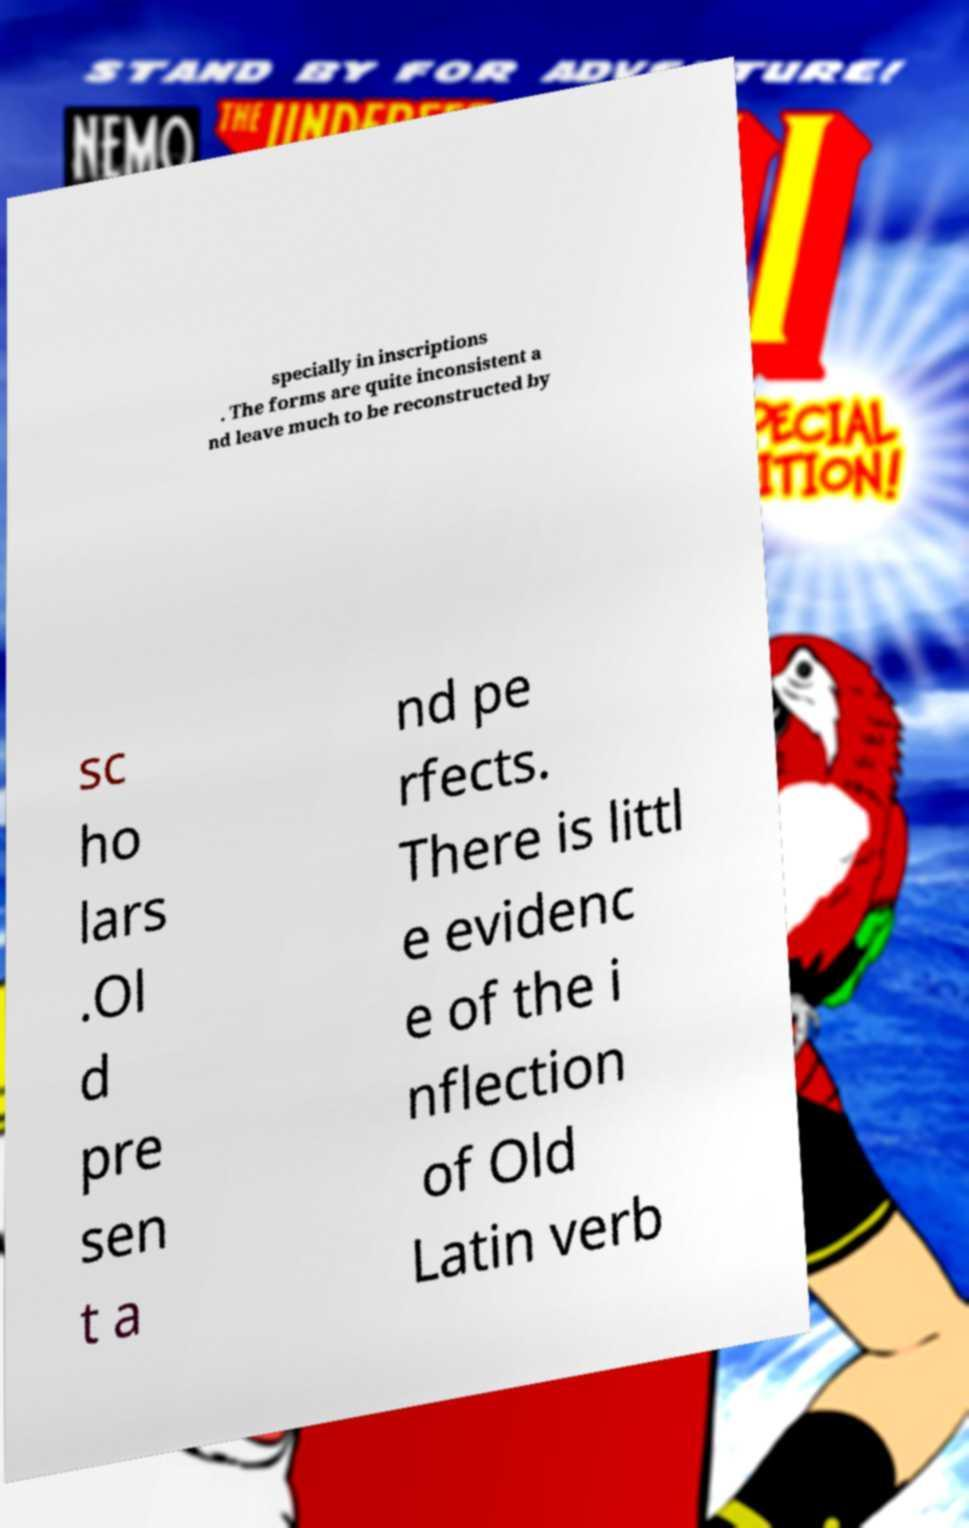Please read and relay the text visible in this image. What does it say? specially in inscriptions . The forms are quite inconsistent a nd leave much to be reconstructed by sc ho lars .Ol d pre sen t a nd pe rfects. There is littl e evidenc e of the i nflection of Old Latin verb 